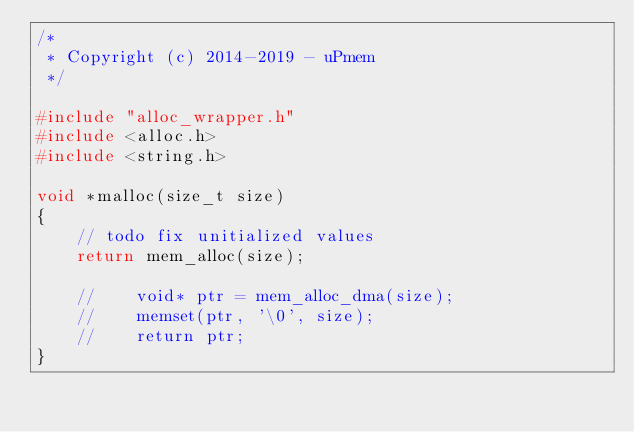Convert code to text. <code><loc_0><loc_0><loc_500><loc_500><_C_>/*
 * Copyright (c) 2014-2019 - uPmem
 */

#include "alloc_wrapper.h"
#include <alloc.h>
#include <string.h>

void *malloc(size_t size)
{
    // todo fix unitialized values
    return mem_alloc(size);

    //    void* ptr = mem_alloc_dma(size);
    //    memset(ptr, '\0', size);
    //    return ptr;
}
</code> 